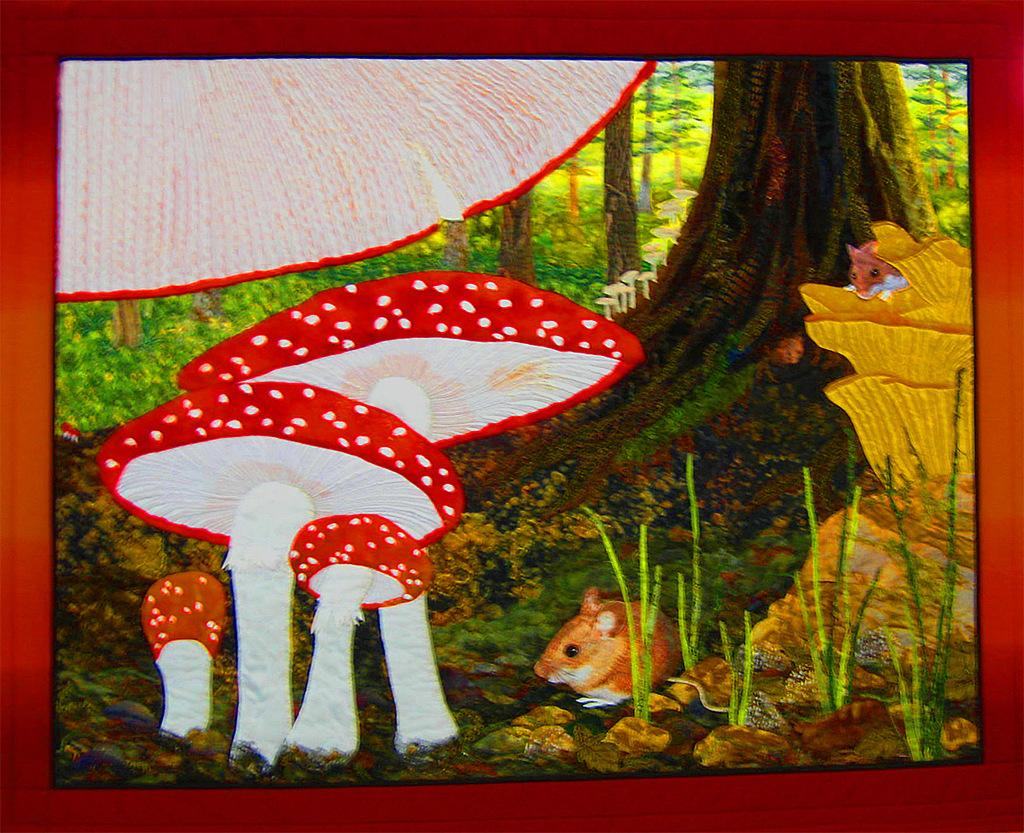What is the main subject of the painting in the image? The painting depicts trees. Are there any animals or creatures in the painting? Yes, there is a mouse in the painting. What other elements can be seen in the painting? The painting features mushrooms. Can you describe any other unspecified elements in the painting? Unfortunately, the facts provided do not specify any other elements in the painting. How many cans of soda are visible in the painting? There are no cans of soda present in the painting; it features trees, a mouse, and mushrooms. 